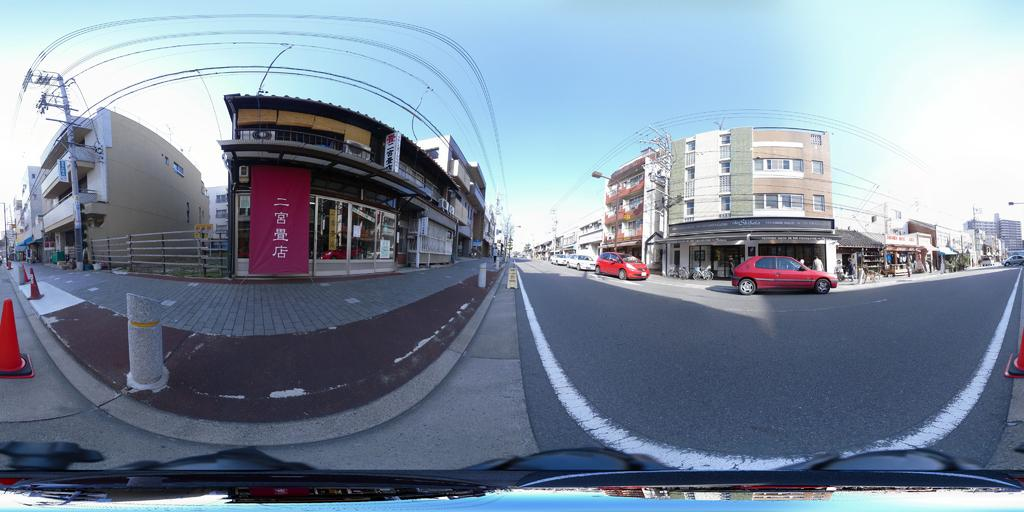What type of structures can be seen in the image? There are buildings in the image. What is the purpose of the walkway in the image? The walkway in the image is likely for pedestrians to walk on. What are the poles used for in the image? The poles in the image might be used for streetlights, traffic signals, or other purposes. What are the traffic cones indicating in the image? The traffic cones in the image might indicate a construction zone, road work, or other temporary obstructions. What is the purpose of the banners in the image? The banners in the image might be advertising, promoting an event, or providing information. What types of vehicles can be seen on the road in the image? Vehicles such as cars, trucks, or buses can be seen on the road in the image. What is visible in the background of the image? The sky is visible in the background of the image. What objects are present at the bottom of the image? Objects such as the walkway, poles, traffic cones, and banners can be seen at the bottom of the image. Where is the pail located in the image? There is no pail present in the image. What is the topic of the discussion taking place in the image? There is no discussion taking place in the image. 